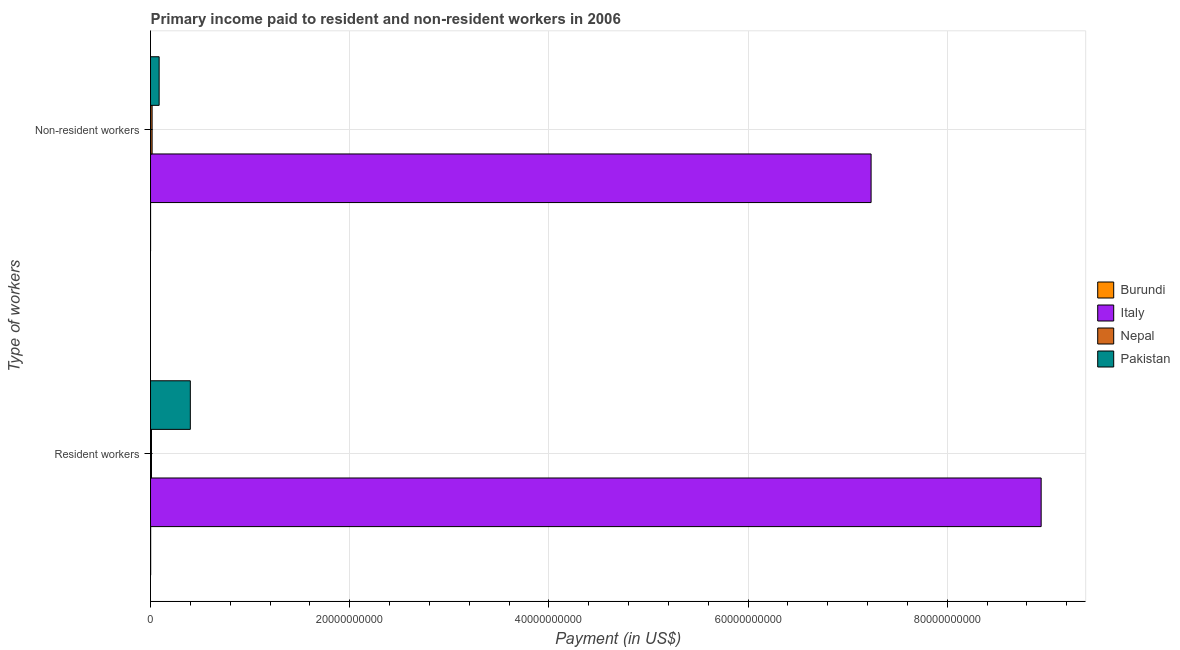How many groups of bars are there?
Keep it short and to the point. 2. How many bars are there on the 2nd tick from the top?
Provide a succinct answer. 4. What is the label of the 1st group of bars from the top?
Your answer should be very brief. Non-resident workers. What is the payment made to resident workers in Burundi?
Make the answer very short. 1.34e+07. Across all countries, what is the maximum payment made to resident workers?
Your response must be concise. 8.94e+1. Across all countries, what is the minimum payment made to resident workers?
Provide a succinct answer. 1.34e+07. In which country was the payment made to non-resident workers minimum?
Your response must be concise. Burundi. What is the total payment made to non-resident workers in the graph?
Your answer should be very brief. 7.34e+1. What is the difference between the payment made to non-resident workers in Italy and that in Nepal?
Your answer should be compact. 7.22e+1. What is the difference between the payment made to non-resident workers in Nepal and the payment made to resident workers in Burundi?
Your answer should be very brief. 1.45e+08. What is the average payment made to resident workers per country?
Your response must be concise. 2.34e+1. What is the difference between the payment made to non-resident workers and payment made to resident workers in Italy?
Your response must be concise. -1.71e+1. What is the ratio of the payment made to resident workers in Nepal to that in Pakistan?
Your answer should be compact. 0.02. Is the payment made to non-resident workers in Pakistan less than that in Nepal?
Make the answer very short. No. What does the 3rd bar from the top in Resident workers represents?
Ensure brevity in your answer.  Italy. What does the 2nd bar from the bottom in Non-resident workers represents?
Ensure brevity in your answer.  Italy. How many bars are there?
Keep it short and to the point. 8. How many countries are there in the graph?
Your response must be concise. 4. Are the values on the major ticks of X-axis written in scientific E-notation?
Provide a short and direct response. No. Does the graph contain any zero values?
Offer a terse response. No. How are the legend labels stacked?
Your answer should be very brief. Vertical. What is the title of the graph?
Keep it short and to the point. Primary income paid to resident and non-resident workers in 2006. Does "Channel Islands" appear as one of the legend labels in the graph?
Your response must be concise. No. What is the label or title of the X-axis?
Give a very brief answer. Payment (in US$). What is the label or title of the Y-axis?
Ensure brevity in your answer.  Type of workers. What is the Payment (in US$) of Burundi in Resident workers?
Ensure brevity in your answer.  1.34e+07. What is the Payment (in US$) of Italy in Resident workers?
Provide a succinct answer. 8.94e+1. What is the Payment (in US$) in Nepal in Resident workers?
Your answer should be very brief. 9.61e+07. What is the Payment (in US$) of Pakistan in Resident workers?
Your answer should be compact. 4.00e+09. What is the Payment (in US$) in Burundi in Non-resident workers?
Provide a succinct answer. 4.61e+06. What is the Payment (in US$) of Italy in Non-resident workers?
Provide a short and direct response. 7.24e+1. What is the Payment (in US$) of Nepal in Non-resident workers?
Ensure brevity in your answer.  1.58e+08. What is the Payment (in US$) of Pakistan in Non-resident workers?
Your response must be concise. 8.64e+08. Across all Type of workers, what is the maximum Payment (in US$) in Burundi?
Offer a very short reply. 1.34e+07. Across all Type of workers, what is the maximum Payment (in US$) in Italy?
Give a very brief answer. 8.94e+1. Across all Type of workers, what is the maximum Payment (in US$) in Nepal?
Make the answer very short. 1.58e+08. Across all Type of workers, what is the maximum Payment (in US$) of Pakistan?
Keep it short and to the point. 4.00e+09. Across all Type of workers, what is the minimum Payment (in US$) in Burundi?
Your response must be concise. 4.61e+06. Across all Type of workers, what is the minimum Payment (in US$) of Italy?
Make the answer very short. 7.24e+1. Across all Type of workers, what is the minimum Payment (in US$) of Nepal?
Offer a terse response. 9.61e+07. Across all Type of workers, what is the minimum Payment (in US$) of Pakistan?
Give a very brief answer. 8.64e+08. What is the total Payment (in US$) in Burundi in the graph?
Provide a short and direct response. 1.81e+07. What is the total Payment (in US$) of Italy in the graph?
Your answer should be very brief. 1.62e+11. What is the total Payment (in US$) in Nepal in the graph?
Your answer should be compact. 2.54e+08. What is the total Payment (in US$) in Pakistan in the graph?
Keep it short and to the point. 4.86e+09. What is the difference between the Payment (in US$) in Burundi in Resident workers and that in Non-resident workers?
Offer a very short reply. 8.82e+06. What is the difference between the Payment (in US$) of Italy in Resident workers and that in Non-resident workers?
Make the answer very short. 1.71e+1. What is the difference between the Payment (in US$) of Nepal in Resident workers and that in Non-resident workers?
Offer a terse response. -6.21e+07. What is the difference between the Payment (in US$) of Pakistan in Resident workers and that in Non-resident workers?
Offer a terse response. 3.13e+09. What is the difference between the Payment (in US$) of Burundi in Resident workers and the Payment (in US$) of Italy in Non-resident workers?
Offer a terse response. -7.23e+1. What is the difference between the Payment (in US$) of Burundi in Resident workers and the Payment (in US$) of Nepal in Non-resident workers?
Keep it short and to the point. -1.45e+08. What is the difference between the Payment (in US$) of Burundi in Resident workers and the Payment (in US$) of Pakistan in Non-resident workers?
Your answer should be compact. -8.51e+08. What is the difference between the Payment (in US$) in Italy in Resident workers and the Payment (in US$) in Nepal in Non-resident workers?
Provide a short and direct response. 8.93e+1. What is the difference between the Payment (in US$) in Italy in Resident workers and the Payment (in US$) in Pakistan in Non-resident workers?
Offer a terse response. 8.86e+1. What is the difference between the Payment (in US$) in Nepal in Resident workers and the Payment (in US$) in Pakistan in Non-resident workers?
Ensure brevity in your answer.  -7.68e+08. What is the average Payment (in US$) of Burundi per Type of workers?
Give a very brief answer. 9.03e+06. What is the average Payment (in US$) of Italy per Type of workers?
Ensure brevity in your answer.  8.09e+1. What is the average Payment (in US$) of Nepal per Type of workers?
Offer a terse response. 1.27e+08. What is the average Payment (in US$) of Pakistan per Type of workers?
Provide a short and direct response. 2.43e+09. What is the difference between the Payment (in US$) in Burundi and Payment (in US$) in Italy in Resident workers?
Your answer should be very brief. -8.94e+1. What is the difference between the Payment (in US$) in Burundi and Payment (in US$) in Nepal in Resident workers?
Provide a short and direct response. -8.26e+07. What is the difference between the Payment (in US$) of Burundi and Payment (in US$) of Pakistan in Resident workers?
Provide a succinct answer. -3.98e+09. What is the difference between the Payment (in US$) in Italy and Payment (in US$) in Nepal in Resident workers?
Offer a terse response. 8.93e+1. What is the difference between the Payment (in US$) of Italy and Payment (in US$) of Pakistan in Resident workers?
Offer a very short reply. 8.54e+1. What is the difference between the Payment (in US$) in Nepal and Payment (in US$) in Pakistan in Resident workers?
Your response must be concise. -3.90e+09. What is the difference between the Payment (in US$) in Burundi and Payment (in US$) in Italy in Non-resident workers?
Ensure brevity in your answer.  -7.23e+1. What is the difference between the Payment (in US$) of Burundi and Payment (in US$) of Nepal in Non-resident workers?
Your response must be concise. -1.54e+08. What is the difference between the Payment (in US$) in Burundi and Payment (in US$) in Pakistan in Non-resident workers?
Offer a terse response. -8.59e+08. What is the difference between the Payment (in US$) in Italy and Payment (in US$) in Nepal in Non-resident workers?
Make the answer very short. 7.22e+1. What is the difference between the Payment (in US$) of Italy and Payment (in US$) of Pakistan in Non-resident workers?
Make the answer very short. 7.15e+1. What is the difference between the Payment (in US$) of Nepal and Payment (in US$) of Pakistan in Non-resident workers?
Offer a very short reply. -7.06e+08. What is the ratio of the Payment (in US$) of Burundi in Resident workers to that in Non-resident workers?
Offer a terse response. 2.91. What is the ratio of the Payment (in US$) of Italy in Resident workers to that in Non-resident workers?
Provide a short and direct response. 1.24. What is the ratio of the Payment (in US$) of Nepal in Resident workers to that in Non-resident workers?
Ensure brevity in your answer.  0.61. What is the ratio of the Payment (in US$) in Pakistan in Resident workers to that in Non-resident workers?
Keep it short and to the point. 4.62. What is the difference between the highest and the second highest Payment (in US$) in Burundi?
Provide a short and direct response. 8.82e+06. What is the difference between the highest and the second highest Payment (in US$) of Italy?
Your answer should be compact. 1.71e+1. What is the difference between the highest and the second highest Payment (in US$) in Nepal?
Your response must be concise. 6.21e+07. What is the difference between the highest and the second highest Payment (in US$) in Pakistan?
Keep it short and to the point. 3.13e+09. What is the difference between the highest and the lowest Payment (in US$) of Burundi?
Give a very brief answer. 8.82e+06. What is the difference between the highest and the lowest Payment (in US$) of Italy?
Offer a very short reply. 1.71e+1. What is the difference between the highest and the lowest Payment (in US$) of Nepal?
Offer a very short reply. 6.21e+07. What is the difference between the highest and the lowest Payment (in US$) in Pakistan?
Provide a succinct answer. 3.13e+09. 